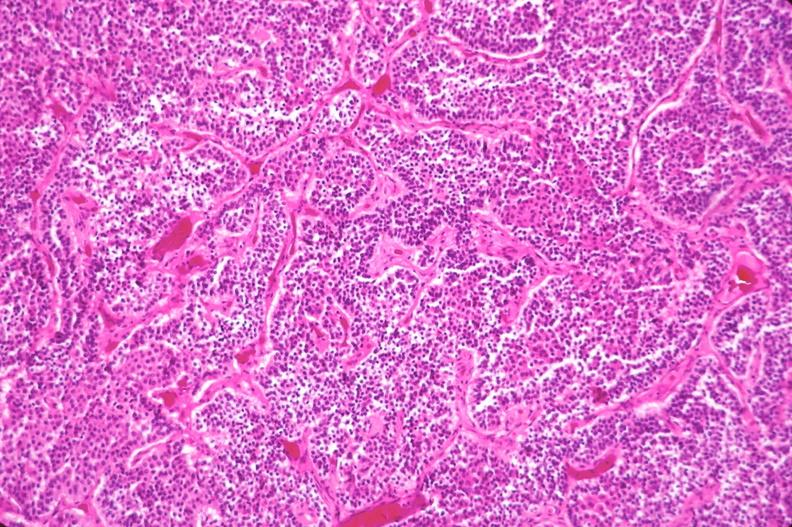where is this part in the figure?
Answer the question using a single word or phrase. Endocrine system 